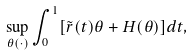<formula> <loc_0><loc_0><loc_500><loc_500>\sup _ { \theta ( \cdot ) } \int _ { 0 } ^ { 1 } [ \tilde { r } ( t ) \theta + H ( \theta ) ] d t ,</formula> 